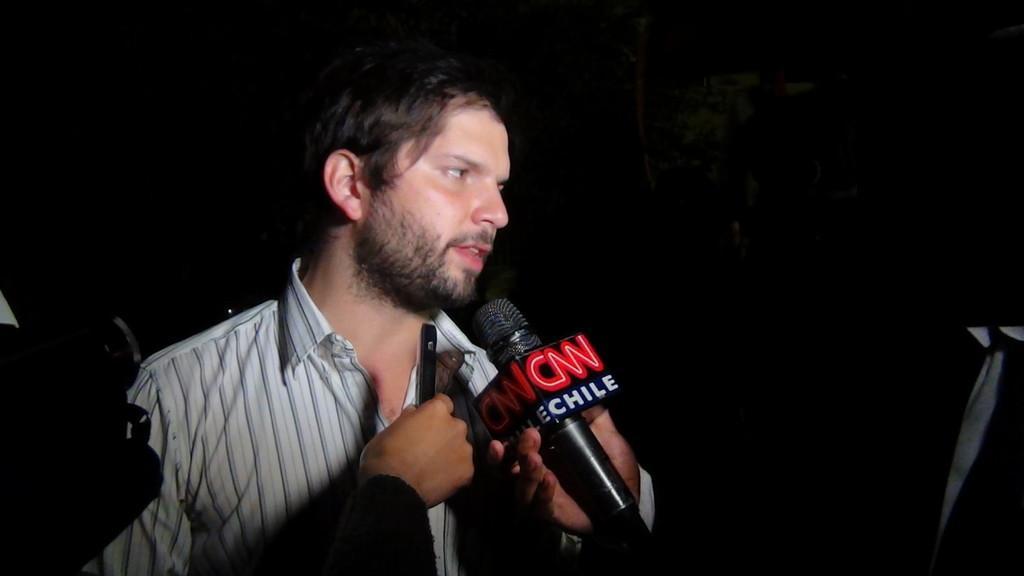Could you give a brief overview of what you see in this image? This person standing. We can see microphone. 